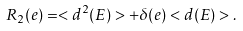Convert formula to latex. <formula><loc_0><loc_0><loc_500><loc_500>R _ { 2 } ( e ) = < d ^ { 2 } ( E ) > + \delta ( e ) < d ( E ) > .</formula> 